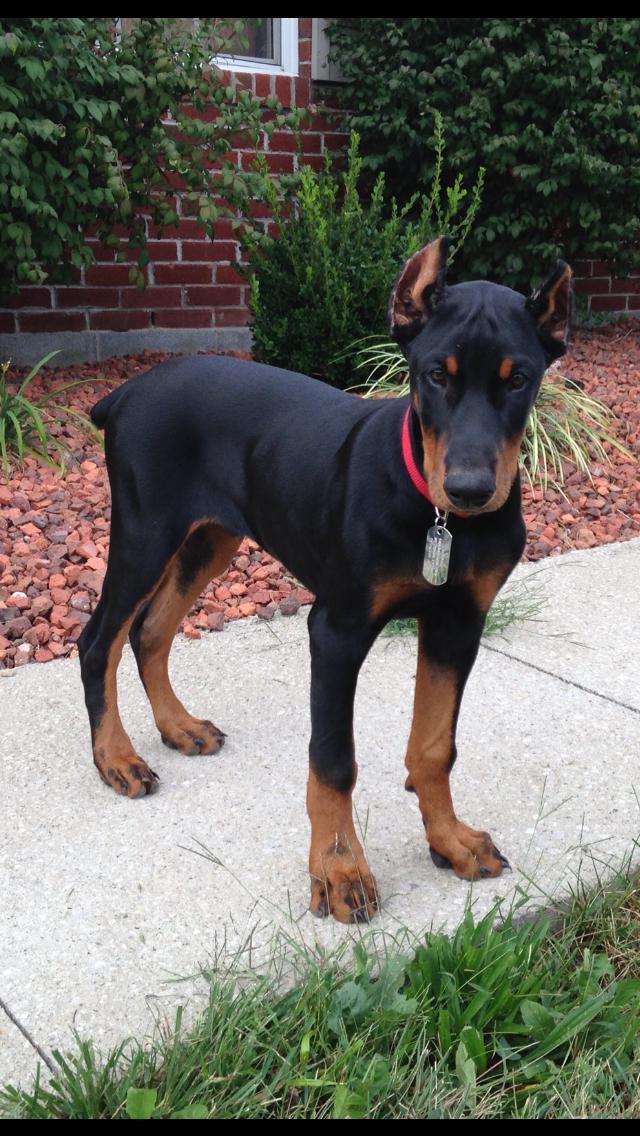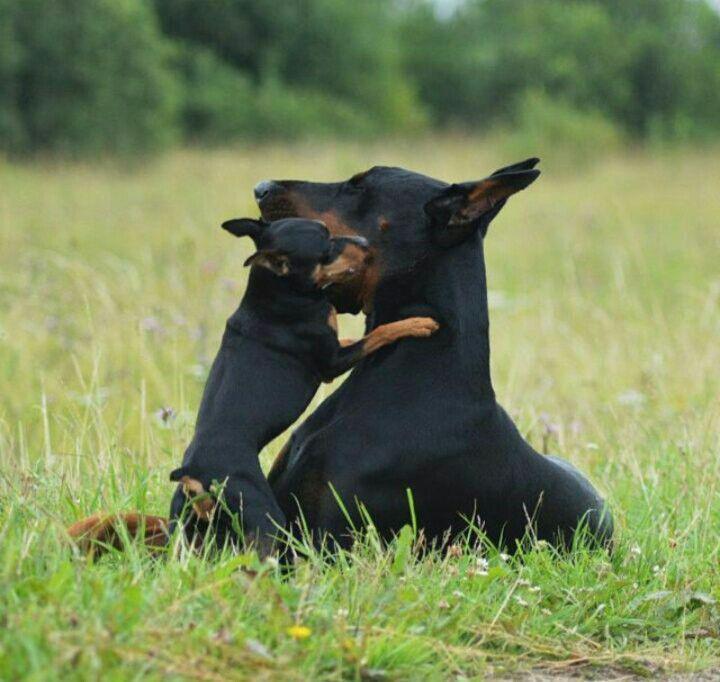The first image is the image on the left, the second image is the image on the right. Given the left and right images, does the statement "There are three dogs and one is a puppy." hold true? Answer yes or no. Yes. The first image is the image on the left, the second image is the image on the right. Given the left and right images, does the statement "there are two dogs on the grass, one of the dogs is laying down" hold true? Answer yes or no. Yes. 